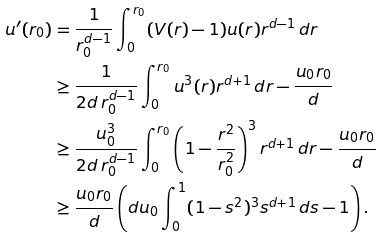Convert formula to latex. <formula><loc_0><loc_0><loc_500><loc_500>u ^ { \prime } ( r _ { 0 } ) & = \frac { 1 } { r _ { 0 } ^ { d - 1 } } \int _ { 0 } ^ { r _ { 0 } } ( V ( r ) - 1 ) u ( r ) r ^ { d - 1 } \, d r \\ & \geq \frac { 1 } { 2 d \, r _ { 0 } ^ { d - 1 } } \int _ { 0 } ^ { r _ { 0 } } u ^ { 3 } ( r ) r ^ { d + 1 } \, d r - \frac { u _ { 0 } r _ { 0 } } { d } \\ & \geq \frac { u _ { 0 } ^ { 3 } } { 2 d \, r _ { 0 } ^ { d - 1 } } \int _ { 0 } ^ { r _ { 0 } } \left ( 1 - \frac { r ^ { 2 } } { r _ { 0 } ^ { 2 } } \right ) ^ { 3 } r ^ { d + 1 } \, d r - \frac { u _ { 0 } r _ { 0 } } { d } \\ & \geq \frac { u _ { 0 } r _ { 0 } } { d } \left ( d u _ { 0 } \int _ { 0 } ^ { 1 } ( 1 - s ^ { 2 } ) ^ { 3 } s ^ { d + 1 } \, d s - 1 \right ) . \\</formula> 